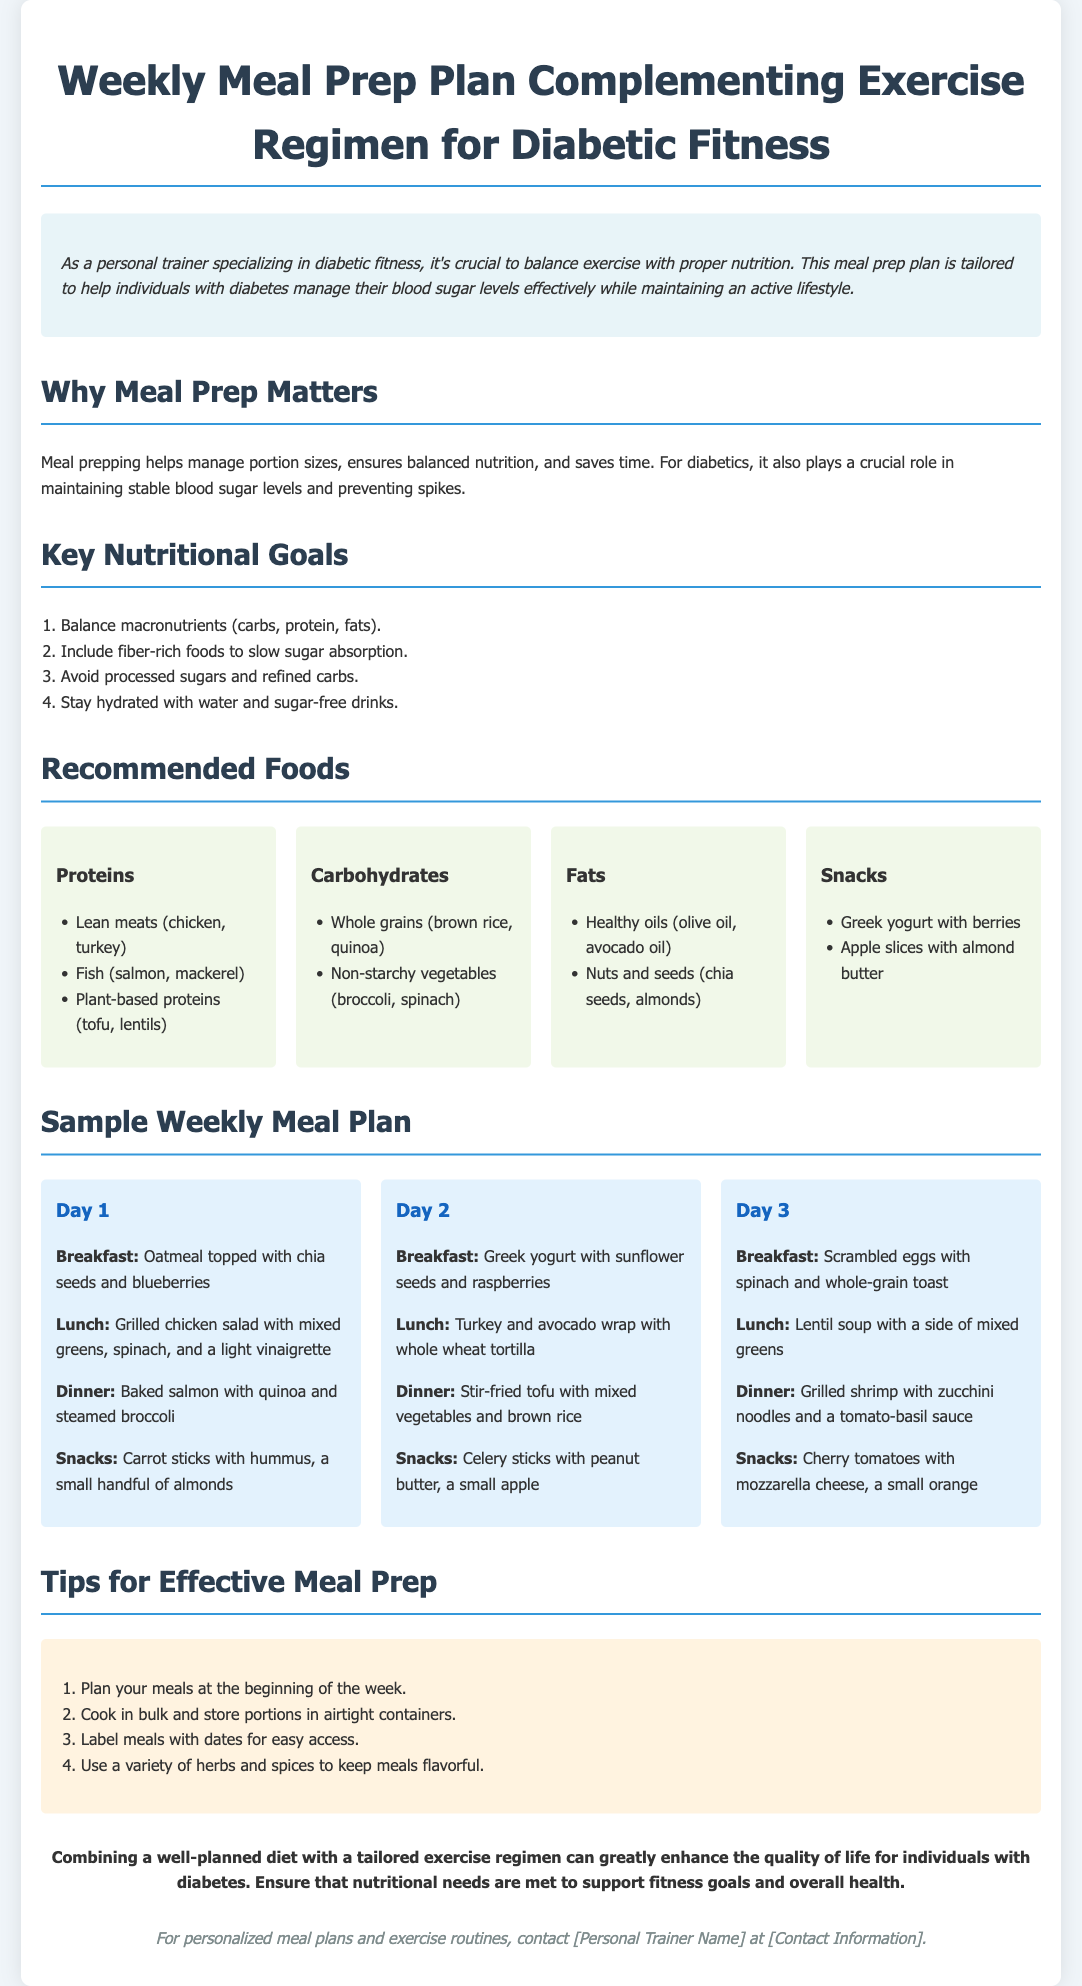What is the title of the document? The title is specified in the header section of the document.
Answer: Weekly Meal Prep Plan Complementing Exercise Regimen for Diabetic Fitness What are the key nutritional goals? The key nutritional goals are listed in an ordered list within the document.
Answer: Balance macronutrients, Include fiber-rich foods, Avoid processed sugars, Stay hydrated Which protein sources are recommended? The recommended protein sources are found in the "Recommended Foods" section of the document.
Answer: Lean meats, Fish, Plant-based proteins What meals are suggested for Day 1? The meal details for Day 1 are clearly outlined under the "Sample Weekly Meal Plan" section of the document.
Answer: Oatmeal, Grilled chicken salad, Baked salmon, Carrot sticks with hummus How many days are covered in the sample meal plan? The document explicitly lists the meal plans for each day, which can be counted.
Answer: 3 days What is one tip for effective meal prep? The tips for effective meal prep are provided in a specific section within the document.
Answer: Plan your meals at the beginning of the week Why is meal prepping important for diabetics? The explanation is given in the introductory paragraphs about meal prepping benefits.
Answer: It helps manage portion sizes and maintains stable blood sugar levels 